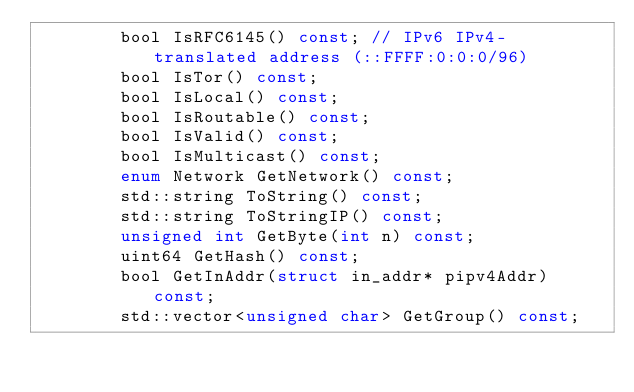<code> <loc_0><loc_0><loc_500><loc_500><_C_>        bool IsRFC6145() const; // IPv6 IPv4-translated address (::FFFF:0:0:0/96)
        bool IsTor() const;
        bool IsLocal() const;
        bool IsRoutable() const;
        bool IsValid() const;
        bool IsMulticast() const;
        enum Network GetNetwork() const;
        std::string ToString() const;
        std::string ToStringIP() const;
        unsigned int GetByte(int n) const;
        uint64 GetHash() const;
        bool GetInAddr(struct in_addr* pipv4Addr) const;
        std::vector<unsigned char> GetGroup() const;</code> 